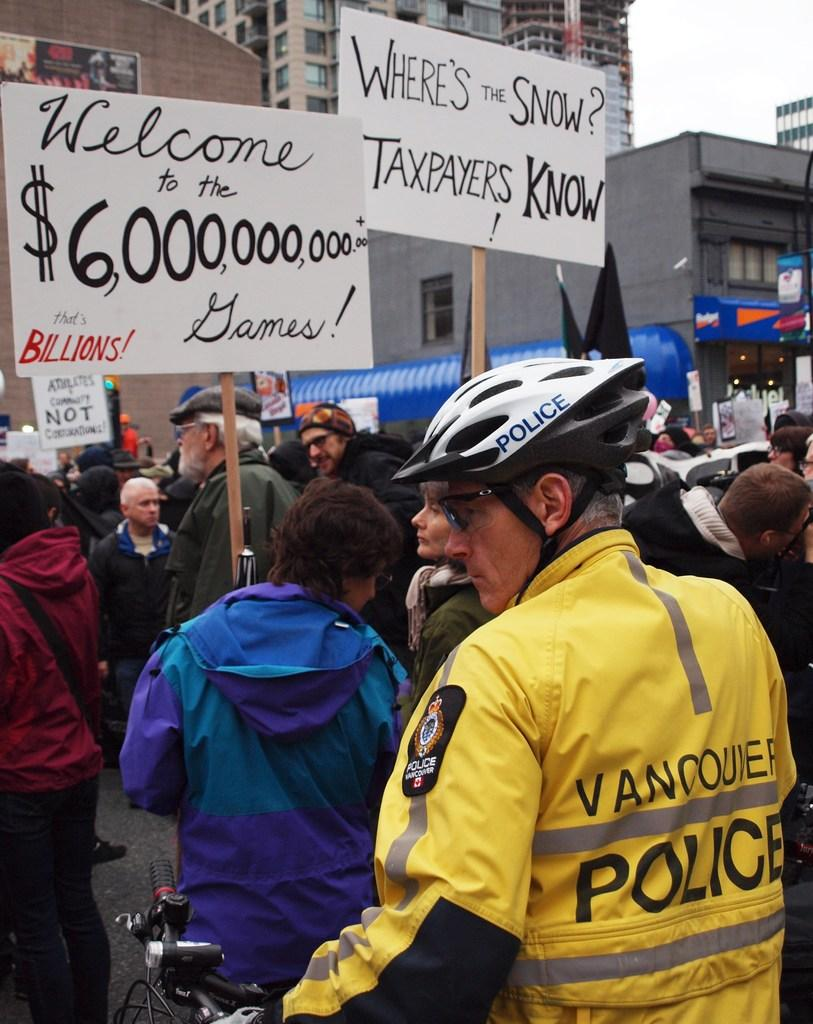What is the occupation of the person on the bicycle in the image? There is a police officer on a bicycle in the image. What are the protesters doing in the image? The protesters are holding placards in the image. What can be seen in the background of the image? There are buildings visible in the image. What type of worm is crawling on the police officer's skirt in the image? There is no worm or skirt present in the image; the police officer is on a bicycle and wearing a uniform. 